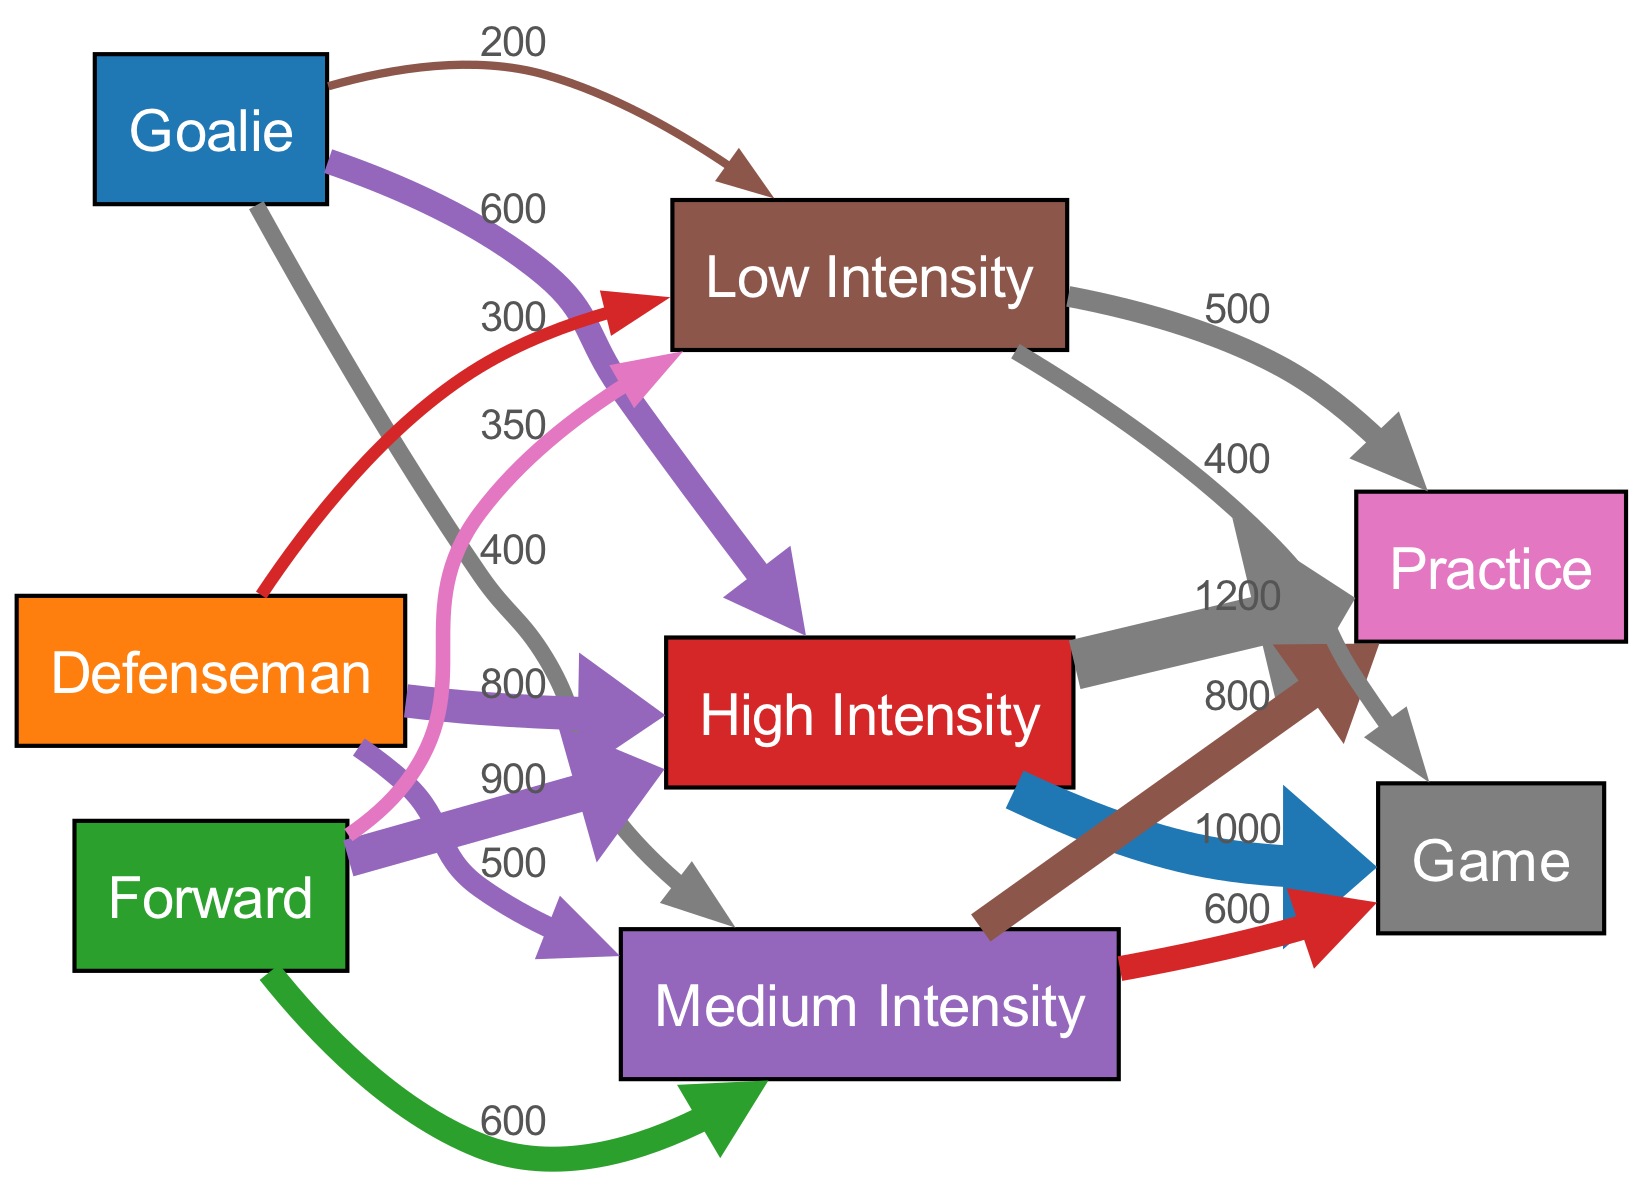What is the total calories burned by Defensemen at high intensity during games? By looking at the link from the Defenseman node to the Game node through High Intensity, the value is 1000 calories.
Answer: 1000 How many calories does a Goalie burn during medium intensity practices? The link from Goalie to Medium Intensity to Practice shows a value of 800 calories.
Answer: 800 Which player position burns the most calories at low intensity during practices? Examining the node for Low Intensity linked to Practice, the Forward position shows the highest value at 350 calories.
Answer: Forward What is the total calories burned by all positions during high intensity games? Summing the edges leading to Game from High Intensity, the values are 1200 from Goalies, 1000 from Defensemen, and 900 from Forwards. The total is 1200 + 1000 + 900 = 3100 calories.
Answer: 3100 Which intensity level has the lowest total calories burned during practices? By adding the values from Practice, Low Intensity has a total of 500 calories compared to High Intensity (1200) and Medium Intensity (800).
Answer: Low Intensity How many total nodes are present in the diagram? Counting both player positions (3), intensity levels (3), and activities (2) gives a total of 8 nodes.
Answer: 8 What percentage of calories burned during practices at high intensity is attributed to Forwards? The total for high intensity practices is 1200 calories. Forwards contribute 900 of that, so the percentage is (900 / 1200) * 100 = 75%.
Answer: 75% Which position has the highest calories burned during low intensity games? The link from Low Intensity to Game shows Defenseman has 300 calories, and Forward has 350 calories. Therefore, Forwards have the highest calories burned.
Answer: Forward What is the edge width representing the calories burned by Medium Intensity in practices? The value for Medium Intensity leading to Practice is 800 calories; dividing by 100 gives an edge width of 8.
Answer: 8 